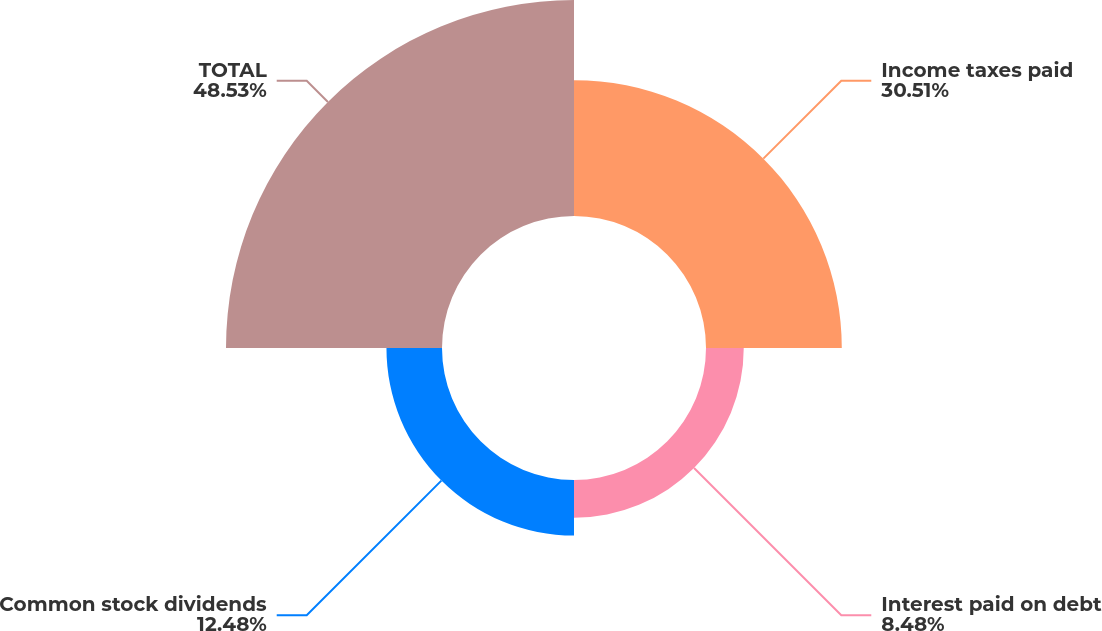<chart> <loc_0><loc_0><loc_500><loc_500><pie_chart><fcel>Income taxes paid<fcel>Interest paid on debt<fcel>Common stock dividends<fcel>TOTAL<nl><fcel>30.51%<fcel>8.48%<fcel>12.48%<fcel>48.53%<nl></chart> 